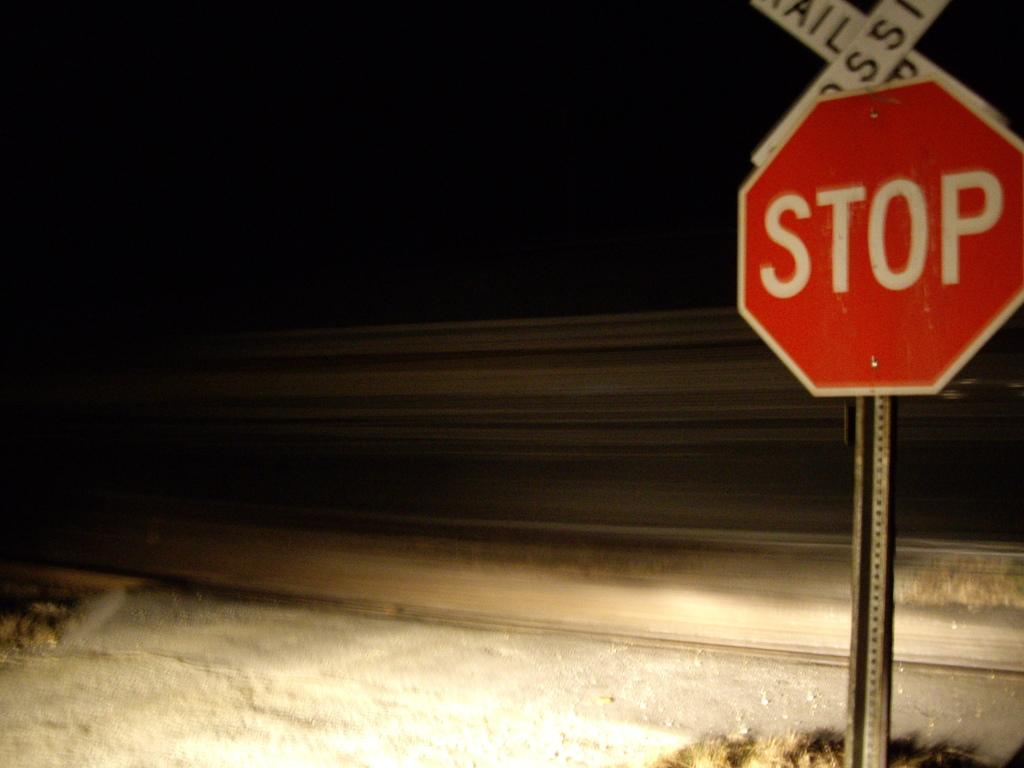<image>
Relay a brief, clear account of the picture shown. A red stop sign stands in front of snowy railroad tracks. 